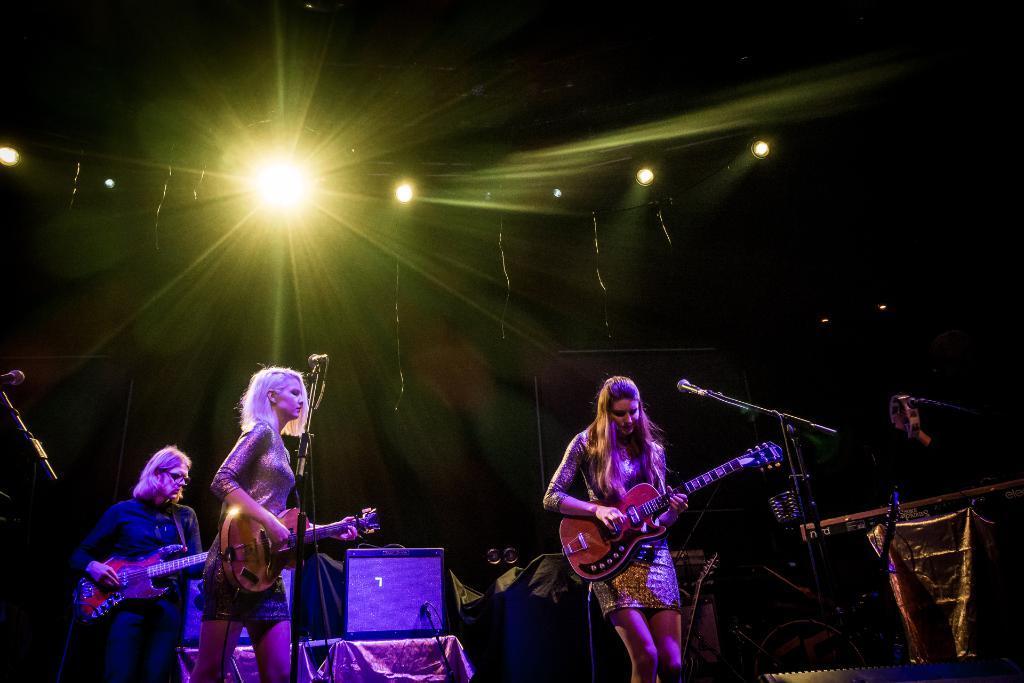Please provide a concise description of this image. Here the three girls are performing musical actions this girl is playing the guitar. This is a microphone here is light. 